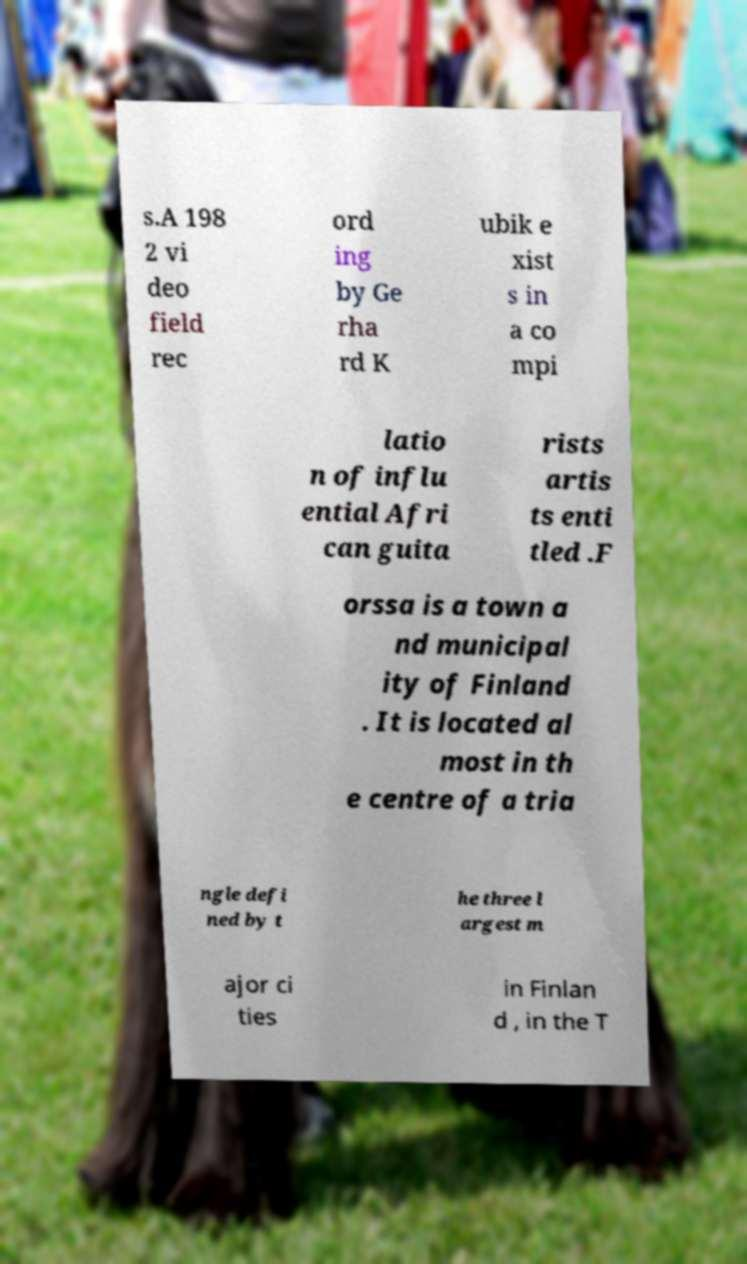Can you read and provide the text displayed in the image?This photo seems to have some interesting text. Can you extract and type it out for me? s.A 198 2 vi deo field rec ord ing by Ge rha rd K ubik e xist s in a co mpi latio n of influ ential Afri can guita rists artis ts enti tled .F orssa is a town a nd municipal ity of Finland . It is located al most in th e centre of a tria ngle defi ned by t he three l argest m ajor ci ties in Finlan d , in the T 